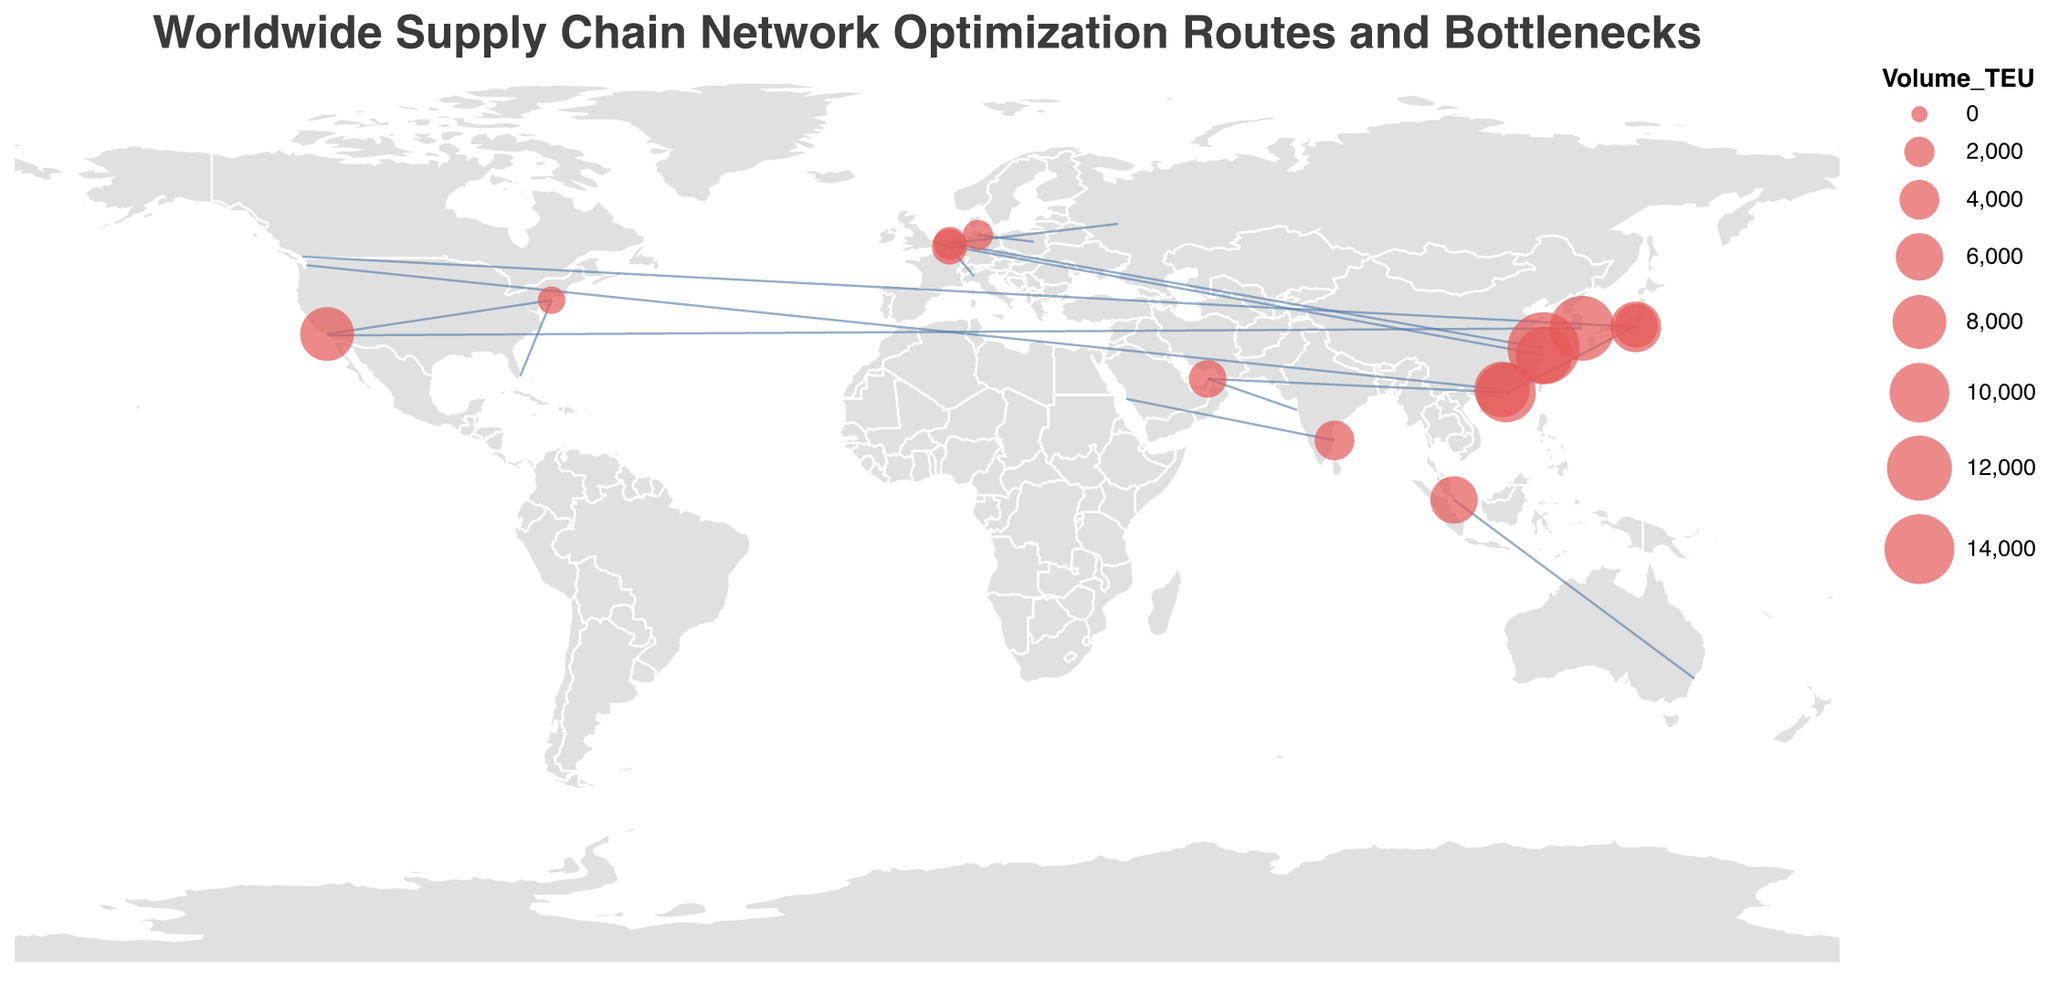What is the main title of the figure? The title is located at the top of the figure and represents the primary subject of the visualization.
Answer: Worldwide Supply Chain Network Optimization Routes and Bottlenecks Which route has the highest delay in hours? The route with the highest delay will have the largest value in the "Delay_Hours" field.
Answer: Yokohama to Vancouver (48 hours) How many maritime routes are shown in the figure? Count the number of routes with the "Route" field labeled as "Maritime".
Answer: 11 What is the total volume (TEU) for all the maritime routes combined? Sum the "Volume_TEU" field for all routes labeled "Maritime" under the "Route" field.
Answer: 85,000 Which bottleneck has the highest volume (TEU) passing through it? Identify the bottleneck with the largest value in the "Volume_TEU" field.
Answer: Suez Canal (15,000 TEU) Compare the delay hours between the routes through the Suez Canal and the Panama Canal. Which one has a higher delay? Find the "Delay_Hours" for the routes labeled with bottlenecks "Suez Canal" and "Panama Canal" and compare them.
Answer: Panama Canal (48 hours vs. 36 hours) What is the average delay time (in hours) for all routes passing through maritime bottlenecks? Calculate the mean of the "Delay_Hours" field for all routes labeled "Maritime". Note: Add all delay hours for maritime routes and divide by the number of maritime routes.
Answer: (36 + 12 + 24 + 48 + 30 + 20 + 16 + 14 + 10 + 40) / 11 = 252 / 11 ≈ 22.91 How does the delay for rail routes compare to road routes? Compare the sum or individual "Delay_Hours" of "Rail" and "Road" labeled routes.
Answer: Rail has a total of 50 hours (18 + 10 + 22) while Road has a total of 14 hours (8 + 6) Which route has the largest volume of TEU between two ports in Asia? Find the highest "Volume_TEU" for routes connecting two Asian ports identified in the "Origin" and "Destination" fields.
Answer: Busan to Long Beach (12,000 TEU) Identify the route with the smallest delay hours. Find the lowest value in the "Delay_Hours" field across all routes.
Answer: New York to Miami (6 hours) 